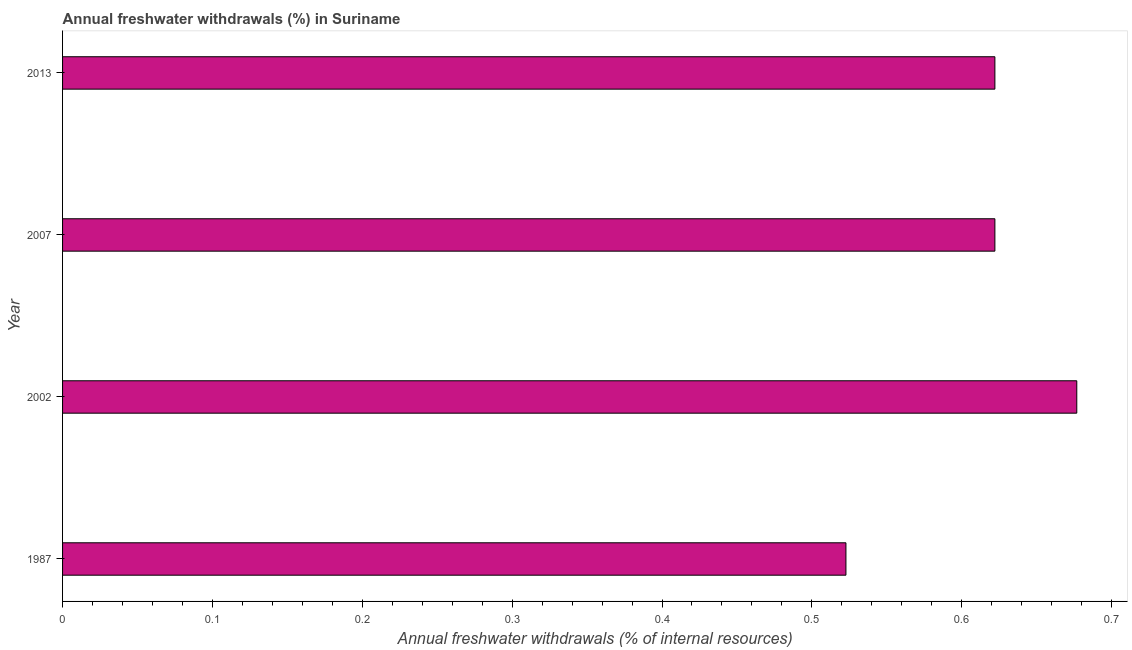Does the graph contain any zero values?
Your answer should be very brief. No. What is the title of the graph?
Your answer should be very brief. Annual freshwater withdrawals (%) in Suriname. What is the label or title of the X-axis?
Your response must be concise. Annual freshwater withdrawals (% of internal resources). What is the annual freshwater withdrawals in 2013?
Ensure brevity in your answer.  0.62. Across all years, what is the maximum annual freshwater withdrawals?
Offer a terse response. 0.68. Across all years, what is the minimum annual freshwater withdrawals?
Provide a short and direct response. 0.52. In which year was the annual freshwater withdrawals maximum?
Give a very brief answer. 2002. What is the sum of the annual freshwater withdrawals?
Keep it short and to the point. 2.44. What is the difference between the annual freshwater withdrawals in 2002 and 2007?
Provide a short and direct response. 0.06. What is the average annual freshwater withdrawals per year?
Keep it short and to the point. 0.61. What is the median annual freshwater withdrawals?
Ensure brevity in your answer.  0.62. Do a majority of the years between 2002 and 2007 (inclusive) have annual freshwater withdrawals greater than 0.08 %?
Provide a short and direct response. Yes. What is the ratio of the annual freshwater withdrawals in 1987 to that in 2007?
Your answer should be compact. 0.84. Is the difference between the annual freshwater withdrawals in 2002 and 2007 greater than the difference between any two years?
Your response must be concise. No. What is the difference between the highest and the second highest annual freshwater withdrawals?
Your answer should be compact. 0.06. In how many years, is the annual freshwater withdrawals greater than the average annual freshwater withdrawals taken over all years?
Provide a short and direct response. 3. How many years are there in the graph?
Keep it short and to the point. 4. What is the difference between two consecutive major ticks on the X-axis?
Provide a short and direct response. 0.1. What is the Annual freshwater withdrawals (% of internal resources) in 1987?
Give a very brief answer. 0.52. What is the Annual freshwater withdrawals (% of internal resources) of 2002?
Keep it short and to the point. 0.68. What is the Annual freshwater withdrawals (% of internal resources) of 2007?
Offer a very short reply. 0.62. What is the Annual freshwater withdrawals (% of internal resources) of 2013?
Your answer should be very brief. 0.62. What is the difference between the Annual freshwater withdrawals (% of internal resources) in 1987 and 2002?
Provide a succinct answer. -0.15. What is the difference between the Annual freshwater withdrawals (% of internal resources) in 1987 and 2007?
Your answer should be compact. -0.1. What is the difference between the Annual freshwater withdrawals (% of internal resources) in 1987 and 2013?
Your answer should be compact. -0.1. What is the difference between the Annual freshwater withdrawals (% of internal resources) in 2002 and 2007?
Offer a very short reply. 0.05. What is the difference between the Annual freshwater withdrawals (% of internal resources) in 2002 and 2013?
Your answer should be very brief. 0.05. What is the ratio of the Annual freshwater withdrawals (% of internal resources) in 1987 to that in 2002?
Keep it short and to the point. 0.77. What is the ratio of the Annual freshwater withdrawals (% of internal resources) in 1987 to that in 2007?
Your answer should be compact. 0.84. What is the ratio of the Annual freshwater withdrawals (% of internal resources) in 1987 to that in 2013?
Ensure brevity in your answer.  0.84. What is the ratio of the Annual freshwater withdrawals (% of internal resources) in 2002 to that in 2007?
Keep it short and to the point. 1.09. What is the ratio of the Annual freshwater withdrawals (% of internal resources) in 2002 to that in 2013?
Offer a very short reply. 1.09. What is the ratio of the Annual freshwater withdrawals (% of internal resources) in 2007 to that in 2013?
Provide a succinct answer. 1. 